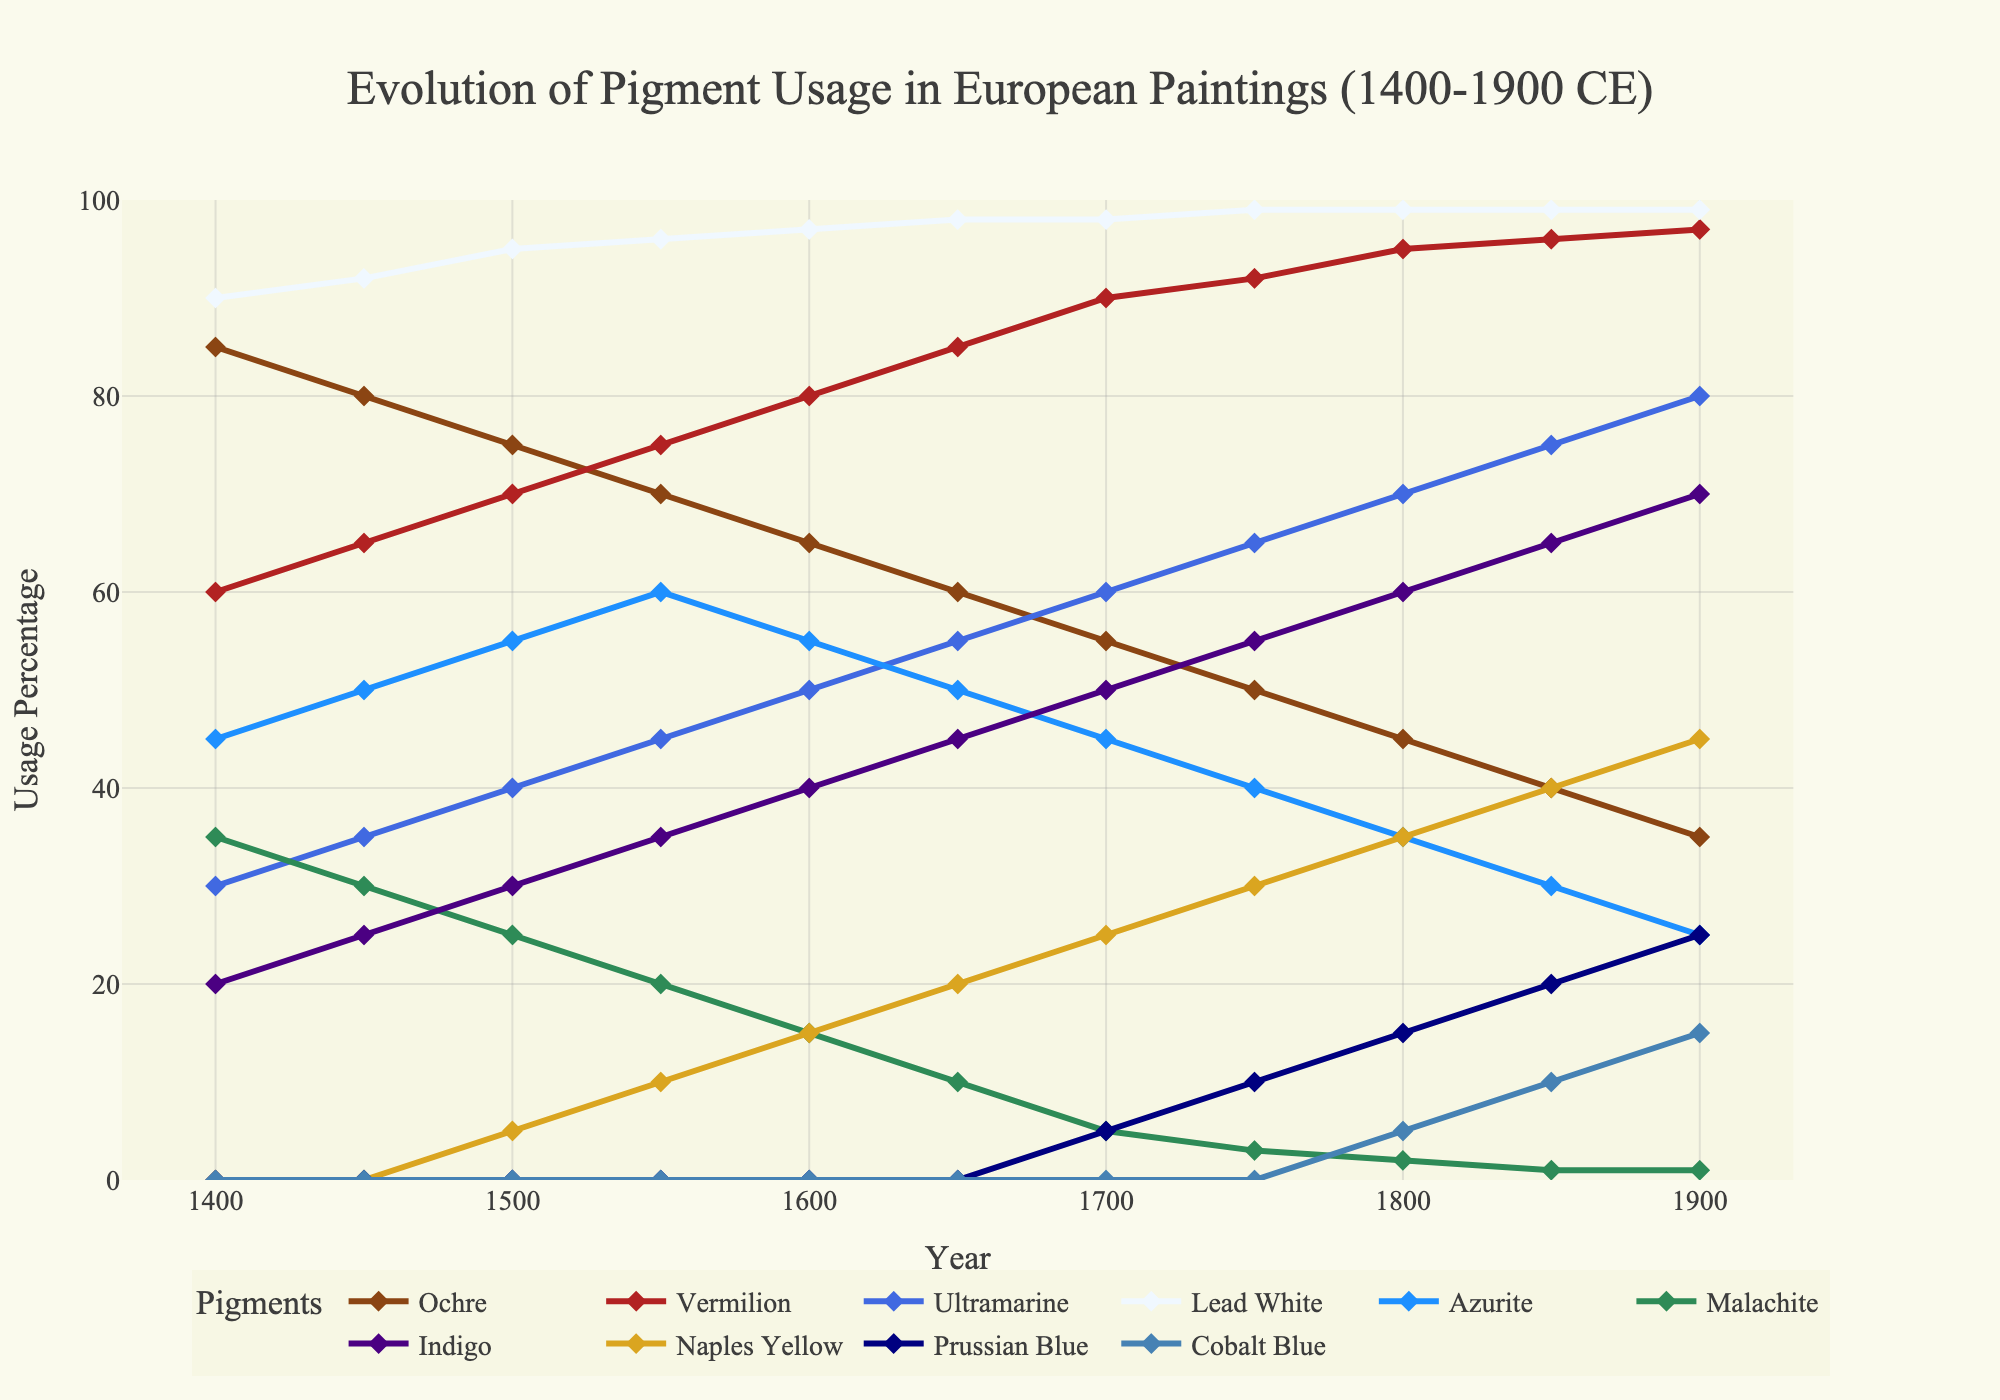What's the most used pigment in 1900? To find the most used pigment in 1900, observe the heights of the markers at 1900 on the x-axis. The highest marker represents Lead White at 99%.
Answer: Lead White Which pigment was introduced last according to the chart? Look for the pigment with usage starting at a later date. Prussian Blue appears first at 1700, while Cobalt Blue appears at 1800.
Answer: Cobalt Blue Between 1400 and 1900, which pigment showed a consistent increase in its usage? Examine the lines for pigments that show a continuous upward trend from 1400 to 1900. Vermilion steadily increases during this period.
Answer: Vermilion Which pigments had higher usage in 1600 compared to 1700? Compare the markers for each pigment at 1600 and 1700. Ochre (65 to 55), Lead White (97 to 98), Azurite (55 to 45), and Malachite (15 to 5) all show decreases.
Answer: Ochre, Lead White, Azurite, Malachite How did the usage of Ultramarine change from 1400 to 1900? Observe the Ultramarine line from 1400 to 1900. It starts at 30% in 1400 and increases to 80% in 1900, indicating a rising trend.
Answer: Increased What is the sum of the usage percentages of Indigo and Naples Yellow in 1550? Add the Indigo and Naples Yellow values at 1550: 35% + 10% = 45%.
Answer: 45% Was Ochre more popular than Ultramarine in 1450? Compare the heights of Ochre and Ultramarine markers at 1450. Ochre is at 80%, and Ultramarine is at 35%.
Answer: Yes What is the percentage difference in Venetian Red usage between 1400 and 1850? Find the difference between Venetian Red values at 1400 (60%) and 1850 (96%): 96% - 60% = 36%.
Answer: 36% Which pigment shows the least usage in 1900? Look for the marker with the lowest value at 1900. Both Azurite and Malachite have a usage of 1%.
Answer: Azurite, Malachite 